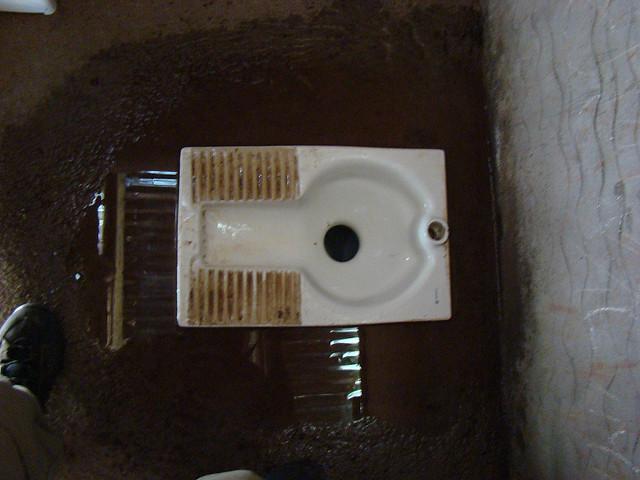How many cares are to the left of the bike rider?
Give a very brief answer. 0. 